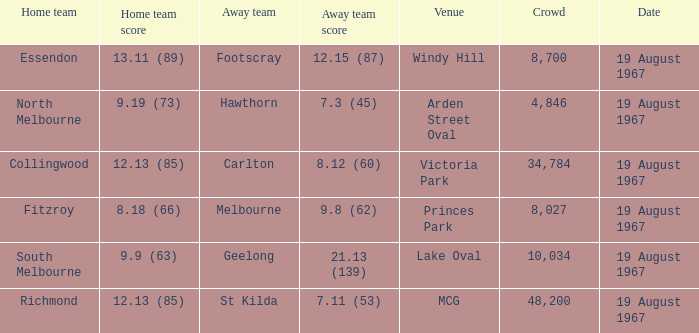If the away team scored 7.3 (45), what was the home team score? 9.19 (73). 